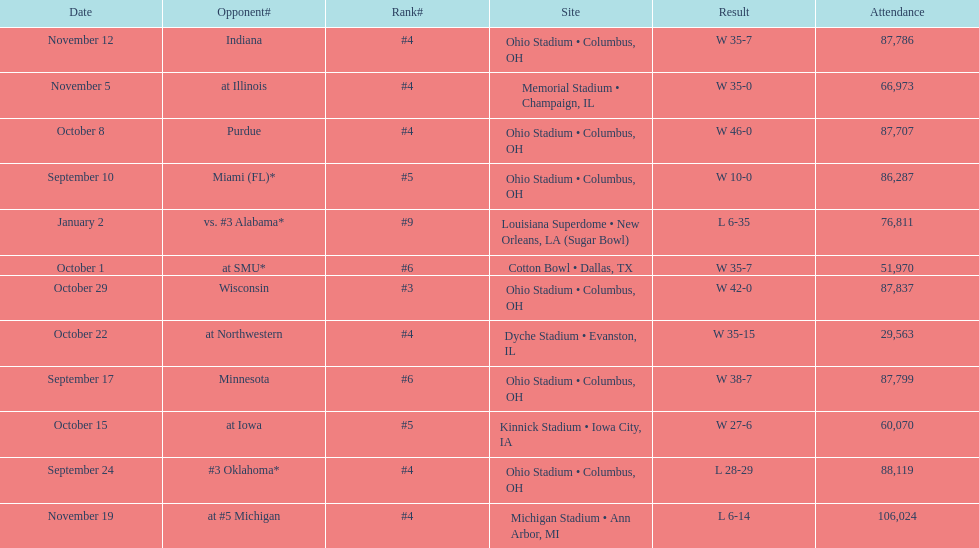Would you mind parsing the complete table? {'header': ['Date', 'Opponent#', 'Rank#', 'Site', 'Result', 'Attendance'], 'rows': [['November 12', 'Indiana', '#4', 'Ohio Stadium • Columbus, OH', 'W\xa035-7', '87,786'], ['November 5', 'at\xa0Illinois', '#4', 'Memorial Stadium • Champaign, IL', 'W\xa035-0', '66,973'], ['October 8', 'Purdue', '#4', 'Ohio Stadium • Columbus, OH', 'W\xa046-0', '87,707'], ['September 10', 'Miami (FL)*', '#5', 'Ohio Stadium • Columbus, OH', 'W\xa010-0', '86,287'], ['January 2', 'vs.\xa0#3\xa0Alabama*', '#9', 'Louisiana Superdome • New Orleans, LA (Sugar Bowl)', 'L\xa06-35', '76,811'], ['October 1', 'at\xa0SMU*', '#6', 'Cotton Bowl • Dallas, TX', 'W\xa035-7', '51,970'], ['October 29', 'Wisconsin', '#3', 'Ohio Stadium • Columbus, OH', 'W\xa042-0', '87,837'], ['October 22', 'at\xa0Northwestern', '#4', 'Dyche Stadium • Evanston, IL', 'W\xa035-15', '29,563'], ['September 17', 'Minnesota', '#6', 'Ohio Stadium • Columbus, OH', 'W\xa038-7', '87,799'], ['October 15', 'at\xa0Iowa', '#5', 'Kinnick Stadium • Iowa City, IA', 'W\xa027-6', '60,070'], ['September 24', '#3\xa0Oklahoma*', '#4', 'Ohio Stadium • Columbus, OH', 'L\xa028-29', '88,119'], ['November 19', 'at\xa0#5\xa0Michigan', '#4', 'Michigan Stadium • Ann Arbor, MI', 'L\xa06-14', '106,024']]} How many dates are on the chart 12. 